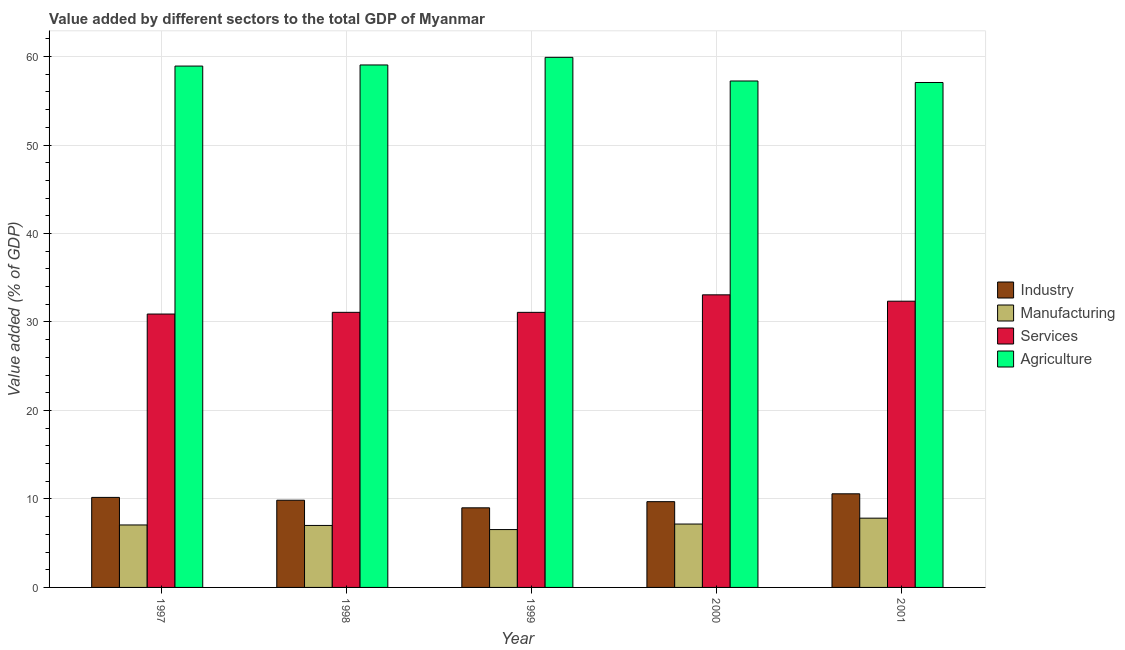Are the number of bars per tick equal to the number of legend labels?
Keep it short and to the point. Yes. Are the number of bars on each tick of the X-axis equal?
Your response must be concise. Yes. How many bars are there on the 2nd tick from the left?
Your answer should be compact. 4. How many bars are there on the 3rd tick from the right?
Offer a terse response. 4. What is the value added by industrial sector in 1999?
Give a very brief answer. 9. Across all years, what is the maximum value added by agricultural sector?
Keep it short and to the point. 59.91. Across all years, what is the minimum value added by manufacturing sector?
Keep it short and to the point. 6.54. In which year was the value added by services sector minimum?
Your response must be concise. 1997. What is the total value added by agricultural sector in the graph?
Offer a terse response. 292.2. What is the difference between the value added by agricultural sector in 1999 and that in 2000?
Offer a terse response. 2.67. What is the difference between the value added by agricultural sector in 2001 and the value added by industrial sector in 1998?
Provide a succinct answer. -1.98. What is the average value added by services sector per year?
Ensure brevity in your answer.  31.7. What is the ratio of the value added by manufacturing sector in 1999 to that in 2001?
Ensure brevity in your answer.  0.84. What is the difference between the highest and the second highest value added by manufacturing sector?
Give a very brief answer. 0.66. What is the difference between the highest and the lowest value added by services sector?
Give a very brief answer. 2.17. Is it the case that in every year, the sum of the value added by industrial sector and value added by services sector is greater than the sum of value added by agricultural sector and value added by manufacturing sector?
Ensure brevity in your answer.  No. What does the 2nd bar from the left in 1997 represents?
Keep it short and to the point. Manufacturing. What does the 4th bar from the right in 1998 represents?
Your answer should be compact. Industry. Are all the bars in the graph horizontal?
Provide a succinct answer. No. How many legend labels are there?
Your response must be concise. 4. How are the legend labels stacked?
Offer a very short reply. Vertical. What is the title of the graph?
Offer a very short reply. Value added by different sectors to the total GDP of Myanmar. What is the label or title of the X-axis?
Provide a succinct answer. Year. What is the label or title of the Y-axis?
Your answer should be compact. Value added (% of GDP). What is the Value added (% of GDP) in Industry in 1997?
Make the answer very short. 10.18. What is the Value added (% of GDP) of Manufacturing in 1997?
Your answer should be compact. 7.06. What is the Value added (% of GDP) in Services in 1997?
Ensure brevity in your answer.  30.9. What is the Value added (% of GDP) in Agriculture in 1997?
Your response must be concise. 58.93. What is the Value added (% of GDP) of Industry in 1998?
Your response must be concise. 9.86. What is the Value added (% of GDP) in Manufacturing in 1998?
Offer a terse response. 7.01. What is the Value added (% of GDP) in Services in 1998?
Provide a short and direct response. 31.09. What is the Value added (% of GDP) of Agriculture in 1998?
Give a very brief answer. 59.05. What is the Value added (% of GDP) of Industry in 1999?
Your answer should be compact. 9. What is the Value added (% of GDP) of Manufacturing in 1999?
Your answer should be compact. 6.54. What is the Value added (% of GDP) in Services in 1999?
Keep it short and to the point. 31.09. What is the Value added (% of GDP) of Agriculture in 1999?
Ensure brevity in your answer.  59.91. What is the Value added (% of GDP) in Industry in 2000?
Offer a terse response. 9.69. What is the Value added (% of GDP) in Manufacturing in 2000?
Give a very brief answer. 7.16. What is the Value added (% of GDP) of Services in 2000?
Provide a short and direct response. 33.07. What is the Value added (% of GDP) of Agriculture in 2000?
Give a very brief answer. 57.24. What is the Value added (% of GDP) in Industry in 2001?
Make the answer very short. 10.58. What is the Value added (% of GDP) of Manufacturing in 2001?
Your response must be concise. 7.83. What is the Value added (% of GDP) of Services in 2001?
Offer a very short reply. 32.35. What is the Value added (% of GDP) of Agriculture in 2001?
Make the answer very short. 57.07. Across all years, what is the maximum Value added (% of GDP) of Industry?
Ensure brevity in your answer.  10.58. Across all years, what is the maximum Value added (% of GDP) in Manufacturing?
Ensure brevity in your answer.  7.83. Across all years, what is the maximum Value added (% of GDP) in Services?
Make the answer very short. 33.07. Across all years, what is the maximum Value added (% of GDP) of Agriculture?
Ensure brevity in your answer.  59.91. Across all years, what is the minimum Value added (% of GDP) in Industry?
Offer a very short reply. 9. Across all years, what is the minimum Value added (% of GDP) of Manufacturing?
Keep it short and to the point. 6.54. Across all years, what is the minimum Value added (% of GDP) of Services?
Offer a terse response. 30.9. Across all years, what is the minimum Value added (% of GDP) in Agriculture?
Make the answer very short. 57.07. What is the total Value added (% of GDP) of Industry in the graph?
Offer a terse response. 49.3. What is the total Value added (% of GDP) in Manufacturing in the graph?
Your response must be concise. 35.6. What is the total Value added (% of GDP) in Services in the graph?
Ensure brevity in your answer.  158.5. What is the total Value added (% of GDP) in Agriculture in the graph?
Ensure brevity in your answer.  292.2. What is the difference between the Value added (% of GDP) of Industry in 1997 and that in 1998?
Offer a very short reply. 0.32. What is the difference between the Value added (% of GDP) of Manufacturing in 1997 and that in 1998?
Offer a very short reply. 0.05. What is the difference between the Value added (% of GDP) in Services in 1997 and that in 1998?
Offer a terse response. -0.19. What is the difference between the Value added (% of GDP) in Agriculture in 1997 and that in 1998?
Offer a very short reply. -0.13. What is the difference between the Value added (% of GDP) of Industry in 1997 and that in 1999?
Offer a very short reply. 1.18. What is the difference between the Value added (% of GDP) in Manufacturing in 1997 and that in 1999?
Your answer should be very brief. 0.52. What is the difference between the Value added (% of GDP) of Services in 1997 and that in 1999?
Provide a succinct answer. -0.19. What is the difference between the Value added (% of GDP) in Agriculture in 1997 and that in 1999?
Provide a succinct answer. -0.99. What is the difference between the Value added (% of GDP) in Industry in 1997 and that in 2000?
Ensure brevity in your answer.  0.48. What is the difference between the Value added (% of GDP) in Manufacturing in 1997 and that in 2000?
Your answer should be very brief. -0.1. What is the difference between the Value added (% of GDP) of Services in 1997 and that in 2000?
Keep it short and to the point. -2.17. What is the difference between the Value added (% of GDP) in Agriculture in 1997 and that in 2000?
Make the answer very short. 1.69. What is the difference between the Value added (% of GDP) in Industry in 1997 and that in 2001?
Your response must be concise. -0.41. What is the difference between the Value added (% of GDP) in Manufacturing in 1997 and that in 2001?
Make the answer very short. -0.77. What is the difference between the Value added (% of GDP) in Services in 1997 and that in 2001?
Provide a short and direct response. -1.45. What is the difference between the Value added (% of GDP) of Agriculture in 1997 and that in 2001?
Give a very brief answer. 1.86. What is the difference between the Value added (% of GDP) of Industry in 1998 and that in 1999?
Offer a terse response. 0.86. What is the difference between the Value added (% of GDP) in Manufacturing in 1998 and that in 1999?
Keep it short and to the point. 0.47. What is the difference between the Value added (% of GDP) of Services in 1998 and that in 1999?
Offer a very short reply. 0. What is the difference between the Value added (% of GDP) of Agriculture in 1998 and that in 1999?
Offer a very short reply. -0.86. What is the difference between the Value added (% of GDP) of Industry in 1998 and that in 2000?
Offer a terse response. 0.17. What is the difference between the Value added (% of GDP) in Manufacturing in 1998 and that in 2000?
Give a very brief answer. -0.16. What is the difference between the Value added (% of GDP) of Services in 1998 and that in 2000?
Give a very brief answer. -1.98. What is the difference between the Value added (% of GDP) of Agriculture in 1998 and that in 2000?
Make the answer very short. 1.81. What is the difference between the Value added (% of GDP) of Industry in 1998 and that in 2001?
Ensure brevity in your answer.  -0.72. What is the difference between the Value added (% of GDP) of Manufacturing in 1998 and that in 2001?
Give a very brief answer. -0.82. What is the difference between the Value added (% of GDP) in Services in 1998 and that in 2001?
Make the answer very short. -1.26. What is the difference between the Value added (% of GDP) of Agriculture in 1998 and that in 2001?
Make the answer very short. 1.98. What is the difference between the Value added (% of GDP) in Industry in 1999 and that in 2000?
Offer a very short reply. -0.69. What is the difference between the Value added (% of GDP) of Manufacturing in 1999 and that in 2000?
Make the answer very short. -0.62. What is the difference between the Value added (% of GDP) of Services in 1999 and that in 2000?
Keep it short and to the point. -1.98. What is the difference between the Value added (% of GDP) of Agriculture in 1999 and that in 2000?
Provide a short and direct response. 2.67. What is the difference between the Value added (% of GDP) of Industry in 1999 and that in 2001?
Ensure brevity in your answer.  -1.58. What is the difference between the Value added (% of GDP) in Manufacturing in 1999 and that in 2001?
Your answer should be compact. -1.29. What is the difference between the Value added (% of GDP) in Services in 1999 and that in 2001?
Your answer should be compact. -1.26. What is the difference between the Value added (% of GDP) of Agriculture in 1999 and that in 2001?
Ensure brevity in your answer.  2.84. What is the difference between the Value added (% of GDP) of Industry in 2000 and that in 2001?
Your answer should be very brief. -0.89. What is the difference between the Value added (% of GDP) of Manufacturing in 2000 and that in 2001?
Your response must be concise. -0.66. What is the difference between the Value added (% of GDP) in Services in 2000 and that in 2001?
Give a very brief answer. 0.72. What is the difference between the Value added (% of GDP) in Agriculture in 2000 and that in 2001?
Your answer should be compact. 0.17. What is the difference between the Value added (% of GDP) of Industry in 1997 and the Value added (% of GDP) of Manufacturing in 1998?
Give a very brief answer. 3.17. What is the difference between the Value added (% of GDP) of Industry in 1997 and the Value added (% of GDP) of Services in 1998?
Ensure brevity in your answer.  -20.92. What is the difference between the Value added (% of GDP) in Industry in 1997 and the Value added (% of GDP) in Agriculture in 1998?
Provide a succinct answer. -48.87. What is the difference between the Value added (% of GDP) of Manufacturing in 1997 and the Value added (% of GDP) of Services in 1998?
Provide a short and direct response. -24.03. What is the difference between the Value added (% of GDP) in Manufacturing in 1997 and the Value added (% of GDP) in Agriculture in 1998?
Provide a short and direct response. -51.99. What is the difference between the Value added (% of GDP) in Services in 1997 and the Value added (% of GDP) in Agriculture in 1998?
Your answer should be compact. -28.15. What is the difference between the Value added (% of GDP) of Industry in 1997 and the Value added (% of GDP) of Manufacturing in 1999?
Make the answer very short. 3.64. What is the difference between the Value added (% of GDP) in Industry in 1997 and the Value added (% of GDP) in Services in 1999?
Provide a succinct answer. -20.91. What is the difference between the Value added (% of GDP) of Industry in 1997 and the Value added (% of GDP) of Agriculture in 1999?
Your answer should be compact. -49.74. What is the difference between the Value added (% of GDP) of Manufacturing in 1997 and the Value added (% of GDP) of Services in 1999?
Keep it short and to the point. -24.03. What is the difference between the Value added (% of GDP) of Manufacturing in 1997 and the Value added (% of GDP) of Agriculture in 1999?
Give a very brief answer. -52.85. What is the difference between the Value added (% of GDP) in Services in 1997 and the Value added (% of GDP) in Agriculture in 1999?
Provide a short and direct response. -29.01. What is the difference between the Value added (% of GDP) in Industry in 1997 and the Value added (% of GDP) in Manufacturing in 2000?
Provide a short and direct response. 3.01. What is the difference between the Value added (% of GDP) of Industry in 1997 and the Value added (% of GDP) of Services in 2000?
Provide a short and direct response. -22.89. What is the difference between the Value added (% of GDP) in Industry in 1997 and the Value added (% of GDP) in Agriculture in 2000?
Offer a terse response. -47.06. What is the difference between the Value added (% of GDP) in Manufacturing in 1997 and the Value added (% of GDP) in Services in 2000?
Provide a succinct answer. -26.01. What is the difference between the Value added (% of GDP) in Manufacturing in 1997 and the Value added (% of GDP) in Agriculture in 2000?
Keep it short and to the point. -50.18. What is the difference between the Value added (% of GDP) of Services in 1997 and the Value added (% of GDP) of Agriculture in 2000?
Provide a short and direct response. -26.34. What is the difference between the Value added (% of GDP) in Industry in 1997 and the Value added (% of GDP) in Manufacturing in 2001?
Keep it short and to the point. 2.35. What is the difference between the Value added (% of GDP) of Industry in 1997 and the Value added (% of GDP) of Services in 2001?
Your answer should be very brief. -22.17. What is the difference between the Value added (% of GDP) of Industry in 1997 and the Value added (% of GDP) of Agriculture in 2001?
Ensure brevity in your answer.  -46.89. What is the difference between the Value added (% of GDP) of Manufacturing in 1997 and the Value added (% of GDP) of Services in 2001?
Provide a short and direct response. -25.29. What is the difference between the Value added (% of GDP) of Manufacturing in 1997 and the Value added (% of GDP) of Agriculture in 2001?
Your answer should be very brief. -50.01. What is the difference between the Value added (% of GDP) in Services in 1997 and the Value added (% of GDP) in Agriculture in 2001?
Make the answer very short. -26.17. What is the difference between the Value added (% of GDP) in Industry in 1998 and the Value added (% of GDP) in Manufacturing in 1999?
Make the answer very short. 3.32. What is the difference between the Value added (% of GDP) in Industry in 1998 and the Value added (% of GDP) in Services in 1999?
Keep it short and to the point. -21.23. What is the difference between the Value added (% of GDP) in Industry in 1998 and the Value added (% of GDP) in Agriculture in 1999?
Your answer should be compact. -50.05. What is the difference between the Value added (% of GDP) in Manufacturing in 1998 and the Value added (% of GDP) in Services in 1999?
Ensure brevity in your answer.  -24.08. What is the difference between the Value added (% of GDP) of Manufacturing in 1998 and the Value added (% of GDP) of Agriculture in 1999?
Ensure brevity in your answer.  -52.91. What is the difference between the Value added (% of GDP) in Services in 1998 and the Value added (% of GDP) in Agriculture in 1999?
Ensure brevity in your answer.  -28.82. What is the difference between the Value added (% of GDP) of Industry in 1998 and the Value added (% of GDP) of Manufacturing in 2000?
Give a very brief answer. 2.69. What is the difference between the Value added (% of GDP) of Industry in 1998 and the Value added (% of GDP) of Services in 2000?
Offer a very short reply. -23.21. What is the difference between the Value added (% of GDP) in Industry in 1998 and the Value added (% of GDP) in Agriculture in 2000?
Provide a short and direct response. -47.38. What is the difference between the Value added (% of GDP) of Manufacturing in 1998 and the Value added (% of GDP) of Services in 2000?
Ensure brevity in your answer.  -26.06. What is the difference between the Value added (% of GDP) in Manufacturing in 1998 and the Value added (% of GDP) in Agriculture in 2000?
Your response must be concise. -50.23. What is the difference between the Value added (% of GDP) in Services in 1998 and the Value added (% of GDP) in Agriculture in 2000?
Make the answer very short. -26.15. What is the difference between the Value added (% of GDP) of Industry in 1998 and the Value added (% of GDP) of Manufacturing in 2001?
Offer a terse response. 2.03. What is the difference between the Value added (% of GDP) of Industry in 1998 and the Value added (% of GDP) of Services in 2001?
Your response must be concise. -22.49. What is the difference between the Value added (% of GDP) of Industry in 1998 and the Value added (% of GDP) of Agriculture in 2001?
Provide a succinct answer. -47.21. What is the difference between the Value added (% of GDP) in Manufacturing in 1998 and the Value added (% of GDP) in Services in 2001?
Your response must be concise. -25.34. What is the difference between the Value added (% of GDP) in Manufacturing in 1998 and the Value added (% of GDP) in Agriculture in 2001?
Offer a very short reply. -50.06. What is the difference between the Value added (% of GDP) of Services in 1998 and the Value added (% of GDP) of Agriculture in 2001?
Ensure brevity in your answer.  -25.98. What is the difference between the Value added (% of GDP) of Industry in 1999 and the Value added (% of GDP) of Manufacturing in 2000?
Ensure brevity in your answer.  1.83. What is the difference between the Value added (% of GDP) of Industry in 1999 and the Value added (% of GDP) of Services in 2000?
Make the answer very short. -24.07. What is the difference between the Value added (% of GDP) of Industry in 1999 and the Value added (% of GDP) of Agriculture in 2000?
Ensure brevity in your answer.  -48.24. What is the difference between the Value added (% of GDP) of Manufacturing in 1999 and the Value added (% of GDP) of Services in 2000?
Provide a succinct answer. -26.53. What is the difference between the Value added (% of GDP) of Manufacturing in 1999 and the Value added (% of GDP) of Agriculture in 2000?
Give a very brief answer. -50.7. What is the difference between the Value added (% of GDP) in Services in 1999 and the Value added (% of GDP) in Agriculture in 2000?
Your answer should be compact. -26.15. What is the difference between the Value added (% of GDP) of Industry in 1999 and the Value added (% of GDP) of Manufacturing in 2001?
Provide a succinct answer. 1.17. What is the difference between the Value added (% of GDP) of Industry in 1999 and the Value added (% of GDP) of Services in 2001?
Your answer should be very brief. -23.35. What is the difference between the Value added (% of GDP) of Industry in 1999 and the Value added (% of GDP) of Agriculture in 2001?
Keep it short and to the point. -48.07. What is the difference between the Value added (% of GDP) in Manufacturing in 1999 and the Value added (% of GDP) in Services in 2001?
Ensure brevity in your answer.  -25.81. What is the difference between the Value added (% of GDP) of Manufacturing in 1999 and the Value added (% of GDP) of Agriculture in 2001?
Your response must be concise. -50.53. What is the difference between the Value added (% of GDP) of Services in 1999 and the Value added (% of GDP) of Agriculture in 2001?
Offer a terse response. -25.98. What is the difference between the Value added (% of GDP) of Industry in 2000 and the Value added (% of GDP) of Manufacturing in 2001?
Offer a terse response. 1.86. What is the difference between the Value added (% of GDP) of Industry in 2000 and the Value added (% of GDP) of Services in 2001?
Your answer should be compact. -22.66. What is the difference between the Value added (% of GDP) in Industry in 2000 and the Value added (% of GDP) in Agriculture in 2001?
Make the answer very short. -47.38. What is the difference between the Value added (% of GDP) of Manufacturing in 2000 and the Value added (% of GDP) of Services in 2001?
Your answer should be very brief. -25.19. What is the difference between the Value added (% of GDP) in Manufacturing in 2000 and the Value added (% of GDP) in Agriculture in 2001?
Give a very brief answer. -49.9. What is the difference between the Value added (% of GDP) of Services in 2000 and the Value added (% of GDP) of Agriculture in 2001?
Provide a succinct answer. -24. What is the average Value added (% of GDP) of Industry per year?
Offer a terse response. 9.86. What is the average Value added (% of GDP) of Manufacturing per year?
Your response must be concise. 7.12. What is the average Value added (% of GDP) in Services per year?
Your answer should be very brief. 31.7. What is the average Value added (% of GDP) of Agriculture per year?
Your answer should be compact. 58.44. In the year 1997, what is the difference between the Value added (% of GDP) in Industry and Value added (% of GDP) in Manufacturing?
Keep it short and to the point. 3.12. In the year 1997, what is the difference between the Value added (% of GDP) in Industry and Value added (% of GDP) in Services?
Provide a short and direct response. -20.72. In the year 1997, what is the difference between the Value added (% of GDP) of Industry and Value added (% of GDP) of Agriculture?
Offer a very short reply. -48.75. In the year 1997, what is the difference between the Value added (% of GDP) in Manufacturing and Value added (% of GDP) in Services?
Ensure brevity in your answer.  -23.84. In the year 1997, what is the difference between the Value added (% of GDP) in Manufacturing and Value added (% of GDP) in Agriculture?
Your answer should be very brief. -51.86. In the year 1997, what is the difference between the Value added (% of GDP) in Services and Value added (% of GDP) in Agriculture?
Your answer should be very brief. -28.03. In the year 1998, what is the difference between the Value added (% of GDP) of Industry and Value added (% of GDP) of Manufacturing?
Offer a very short reply. 2.85. In the year 1998, what is the difference between the Value added (% of GDP) of Industry and Value added (% of GDP) of Services?
Provide a short and direct response. -21.23. In the year 1998, what is the difference between the Value added (% of GDP) in Industry and Value added (% of GDP) in Agriculture?
Offer a very short reply. -49.19. In the year 1998, what is the difference between the Value added (% of GDP) of Manufacturing and Value added (% of GDP) of Services?
Ensure brevity in your answer.  -24.09. In the year 1998, what is the difference between the Value added (% of GDP) of Manufacturing and Value added (% of GDP) of Agriculture?
Your answer should be compact. -52.04. In the year 1998, what is the difference between the Value added (% of GDP) in Services and Value added (% of GDP) in Agriculture?
Offer a terse response. -27.96. In the year 1999, what is the difference between the Value added (% of GDP) of Industry and Value added (% of GDP) of Manufacturing?
Ensure brevity in your answer.  2.46. In the year 1999, what is the difference between the Value added (% of GDP) of Industry and Value added (% of GDP) of Services?
Provide a succinct answer. -22.09. In the year 1999, what is the difference between the Value added (% of GDP) of Industry and Value added (% of GDP) of Agriculture?
Offer a very short reply. -50.92. In the year 1999, what is the difference between the Value added (% of GDP) in Manufacturing and Value added (% of GDP) in Services?
Provide a short and direct response. -24.55. In the year 1999, what is the difference between the Value added (% of GDP) of Manufacturing and Value added (% of GDP) of Agriculture?
Keep it short and to the point. -53.37. In the year 1999, what is the difference between the Value added (% of GDP) in Services and Value added (% of GDP) in Agriculture?
Keep it short and to the point. -28.82. In the year 2000, what is the difference between the Value added (% of GDP) of Industry and Value added (% of GDP) of Manufacturing?
Your answer should be very brief. 2.53. In the year 2000, what is the difference between the Value added (% of GDP) of Industry and Value added (% of GDP) of Services?
Your answer should be very brief. -23.38. In the year 2000, what is the difference between the Value added (% of GDP) of Industry and Value added (% of GDP) of Agriculture?
Provide a short and direct response. -47.55. In the year 2000, what is the difference between the Value added (% of GDP) in Manufacturing and Value added (% of GDP) in Services?
Your answer should be very brief. -25.9. In the year 2000, what is the difference between the Value added (% of GDP) in Manufacturing and Value added (% of GDP) in Agriculture?
Provide a succinct answer. -50.07. In the year 2000, what is the difference between the Value added (% of GDP) of Services and Value added (% of GDP) of Agriculture?
Provide a succinct answer. -24.17. In the year 2001, what is the difference between the Value added (% of GDP) of Industry and Value added (% of GDP) of Manufacturing?
Provide a short and direct response. 2.75. In the year 2001, what is the difference between the Value added (% of GDP) of Industry and Value added (% of GDP) of Services?
Offer a terse response. -21.77. In the year 2001, what is the difference between the Value added (% of GDP) of Industry and Value added (% of GDP) of Agriculture?
Make the answer very short. -46.49. In the year 2001, what is the difference between the Value added (% of GDP) in Manufacturing and Value added (% of GDP) in Services?
Provide a succinct answer. -24.52. In the year 2001, what is the difference between the Value added (% of GDP) of Manufacturing and Value added (% of GDP) of Agriculture?
Make the answer very short. -49.24. In the year 2001, what is the difference between the Value added (% of GDP) in Services and Value added (% of GDP) in Agriculture?
Provide a short and direct response. -24.72. What is the ratio of the Value added (% of GDP) in Industry in 1997 to that in 1998?
Provide a succinct answer. 1.03. What is the ratio of the Value added (% of GDP) of Industry in 1997 to that in 1999?
Your answer should be very brief. 1.13. What is the ratio of the Value added (% of GDP) in Manufacturing in 1997 to that in 1999?
Your response must be concise. 1.08. What is the ratio of the Value added (% of GDP) in Services in 1997 to that in 1999?
Provide a succinct answer. 0.99. What is the ratio of the Value added (% of GDP) of Agriculture in 1997 to that in 1999?
Your answer should be very brief. 0.98. What is the ratio of the Value added (% of GDP) of Industry in 1997 to that in 2000?
Offer a very short reply. 1.05. What is the ratio of the Value added (% of GDP) of Manufacturing in 1997 to that in 2000?
Keep it short and to the point. 0.99. What is the ratio of the Value added (% of GDP) in Services in 1997 to that in 2000?
Keep it short and to the point. 0.93. What is the ratio of the Value added (% of GDP) of Agriculture in 1997 to that in 2000?
Offer a terse response. 1.03. What is the ratio of the Value added (% of GDP) in Industry in 1997 to that in 2001?
Offer a very short reply. 0.96. What is the ratio of the Value added (% of GDP) in Manufacturing in 1997 to that in 2001?
Your answer should be compact. 0.9. What is the ratio of the Value added (% of GDP) of Services in 1997 to that in 2001?
Your answer should be compact. 0.96. What is the ratio of the Value added (% of GDP) in Agriculture in 1997 to that in 2001?
Provide a short and direct response. 1.03. What is the ratio of the Value added (% of GDP) of Industry in 1998 to that in 1999?
Your answer should be very brief. 1.1. What is the ratio of the Value added (% of GDP) in Manufacturing in 1998 to that in 1999?
Your answer should be compact. 1.07. What is the ratio of the Value added (% of GDP) in Services in 1998 to that in 1999?
Your answer should be very brief. 1. What is the ratio of the Value added (% of GDP) of Agriculture in 1998 to that in 1999?
Offer a very short reply. 0.99. What is the ratio of the Value added (% of GDP) in Industry in 1998 to that in 2000?
Offer a terse response. 1.02. What is the ratio of the Value added (% of GDP) of Manufacturing in 1998 to that in 2000?
Make the answer very short. 0.98. What is the ratio of the Value added (% of GDP) in Services in 1998 to that in 2000?
Provide a short and direct response. 0.94. What is the ratio of the Value added (% of GDP) in Agriculture in 1998 to that in 2000?
Offer a terse response. 1.03. What is the ratio of the Value added (% of GDP) in Industry in 1998 to that in 2001?
Keep it short and to the point. 0.93. What is the ratio of the Value added (% of GDP) in Manufacturing in 1998 to that in 2001?
Keep it short and to the point. 0.89. What is the ratio of the Value added (% of GDP) in Services in 1998 to that in 2001?
Make the answer very short. 0.96. What is the ratio of the Value added (% of GDP) in Agriculture in 1998 to that in 2001?
Your response must be concise. 1.03. What is the ratio of the Value added (% of GDP) of Industry in 1999 to that in 2000?
Your response must be concise. 0.93. What is the ratio of the Value added (% of GDP) of Manufacturing in 1999 to that in 2000?
Your answer should be very brief. 0.91. What is the ratio of the Value added (% of GDP) of Services in 1999 to that in 2000?
Offer a very short reply. 0.94. What is the ratio of the Value added (% of GDP) of Agriculture in 1999 to that in 2000?
Your answer should be compact. 1.05. What is the ratio of the Value added (% of GDP) of Industry in 1999 to that in 2001?
Keep it short and to the point. 0.85. What is the ratio of the Value added (% of GDP) of Manufacturing in 1999 to that in 2001?
Provide a succinct answer. 0.84. What is the ratio of the Value added (% of GDP) in Agriculture in 1999 to that in 2001?
Ensure brevity in your answer.  1.05. What is the ratio of the Value added (% of GDP) of Industry in 2000 to that in 2001?
Make the answer very short. 0.92. What is the ratio of the Value added (% of GDP) in Manufacturing in 2000 to that in 2001?
Offer a terse response. 0.92. What is the ratio of the Value added (% of GDP) of Services in 2000 to that in 2001?
Ensure brevity in your answer.  1.02. What is the ratio of the Value added (% of GDP) of Agriculture in 2000 to that in 2001?
Offer a terse response. 1. What is the difference between the highest and the second highest Value added (% of GDP) of Industry?
Give a very brief answer. 0.41. What is the difference between the highest and the second highest Value added (% of GDP) in Manufacturing?
Provide a succinct answer. 0.66. What is the difference between the highest and the second highest Value added (% of GDP) in Services?
Provide a short and direct response. 0.72. What is the difference between the highest and the second highest Value added (% of GDP) in Agriculture?
Your response must be concise. 0.86. What is the difference between the highest and the lowest Value added (% of GDP) of Industry?
Make the answer very short. 1.58. What is the difference between the highest and the lowest Value added (% of GDP) in Manufacturing?
Offer a terse response. 1.29. What is the difference between the highest and the lowest Value added (% of GDP) of Services?
Your answer should be compact. 2.17. What is the difference between the highest and the lowest Value added (% of GDP) in Agriculture?
Provide a short and direct response. 2.84. 